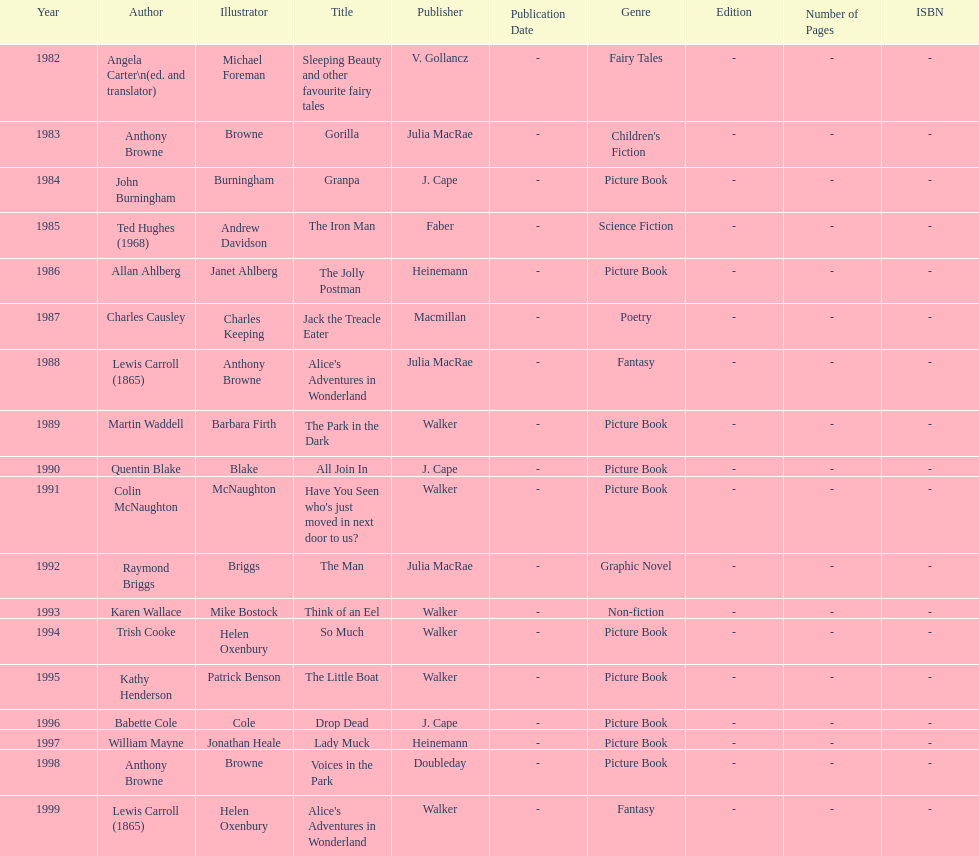Which author wrote the first award winner? Angela Carter. 